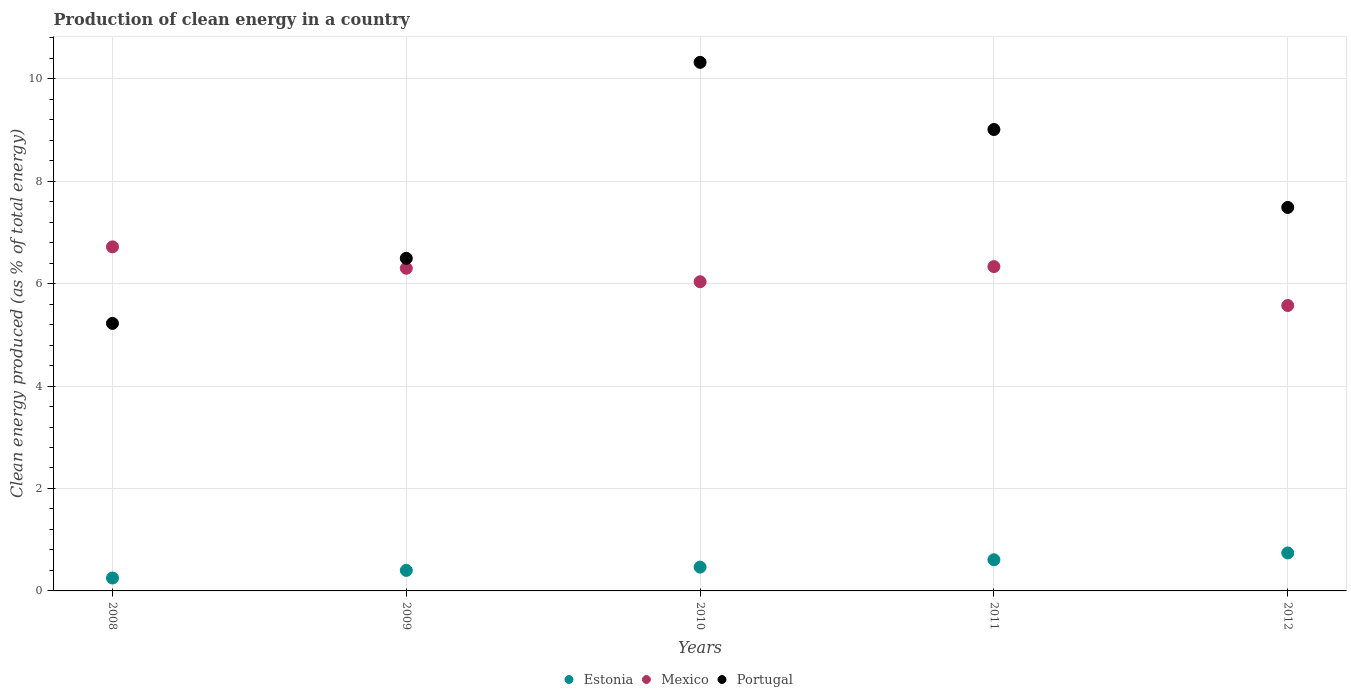How many different coloured dotlines are there?
Offer a terse response. 3. What is the percentage of clean energy produced in Estonia in 2012?
Provide a short and direct response. 0.74. Across all years, what is the maximum percentage of clean energy produced in Estonia?
Offer a very short reply. 0.74. Across all years, what is the minimum percentage of clean energy produced in Portugal?
Keep it short and to the point. 5.22. In which year was the percentage of clean energy produced in Portugal maximum?
Provide a succinct answer. 2010. In which year was the percentage of clean energy produced in Estonia minimum?
Make the answer very short. 2008. What is the total percentage of clean energy produced in Portugal in the graph?
Make the answer very short. 38.53. What is the difference between the percentage of clean energy produced in Mexico in 2008 and that in 2011?
Offer a very short reply. 0.39. What is the difference between the percentage of clean energy produced in Mexico in 2011 and the percentage of clean energy produced in Estonia in 2010?
Ensure brevity in your answer.  5.87. What is the average percentage of clean energy produced in Mexico per year?
Your response must be concise. 6.19. In the year 2011, what is the difference between the percentage of clean energy produced in Portugal and percentage of clean energy produced in Estonia?
Make the answer very short. 8.4. What is the ratio of the percentage of clean energy produced in Mexico in 2009 to that in 2011?
Give a very brief answer. 0.99. What is the difference between the highest and the second highest percentage of clean energy produced in Mexico?
Provide a short and direct response. 0.39. What is the difference between the highest and the lowest percentage of clean energy produced in Estonia?
Ensure brevity in your answer.  0.49. In how many years, is the percentage of clean energy produced in Portugal greater than the average percentage of clean energy produced in Portugal taken over all years?
Keep it short and to the point. 2. Is the sum of the percentage of clean energy produced in Estonia in 2010 and 2011 greater than the maximum percentage of clean energy produced in Mexico across all years?
Your answer should be very brief. No. Is the percentage of clean energy produced in Portugal strictly greater than the percentage of clean energy produced in Mexico over the years?
Give a very brief answer. No. Is the percentage of clean energy produced in Estonia strictly less than the percentage of clean energy produced in Portugal over the years?
Offer a very short reply. Yes. How many dotlines are there?
Provide a short and direct response. 3. What is the difference between two consecutive major ticks on the Y-axis?
Ensure brevity in your answer.  2. How are the legend labels stacked?
Ensure brevity in your answer.  Horizontal. What is the title of the graph?
Provide a short and direct response. Production of clean energy in a country. What is the label or title of the Y-axis?
Ensure brevity in your answer.  Clean energy produced (as % of total energy). What is the Clean energy produced (as % of total energy) of Estonia in 2008?
Your response must be concise. 0.25. What is the Clean energy produced (as % of total energy) in Mexico in 2008?
Your response must be concise. 6.72. What is the Clean energy produced (as % of total energy) of Portugal in 2008?
Provide a succinct answer. 5.22. What is the Clean energy produced (as % of total energy) in Estonia in 2009?
Offer a terse response. 0.4. What is the Clean energy produced (as % of total energy) of Mexico in 2009?
Keep it short and to the point. 6.3. What is the Clean energy produced (as % of total energy) of Portugal in 2009?
Offer a terse response. 6.49. What is the Clean energy produced (as % of total energy) in Estonia in 2010?
Ensure brevity in your answer.  0.46. What is the Clean energy produced (as % of total energy) in Mexico in 2010?
Offer a very short reply. 6.04. What is the Clean energy produced (as % of total energy) of Portugal in 2010?
Your answer should be compact. 10.32. What is the Clean energy produced (as % of total energy) in Estonia in 2011?
Keep it short and to the point. 0.61. What is the Clean energy produced (as % of total energy) of Mexico in 2011?
Ensure brevity in your answer.  6.33. What is the Clean energy produced (as % of total energy) of Portugal in 2011?
Provide a succinct answer. 9.01. What is the Clean energy produced (as % of total energy) of Estonia in 2012?
Provide a short and direct response. 0.74. What is the Clean energy produced (as % of total energy) in Mexico in 2012?
Keep it short and to the point. 5.57. What is the Clean energy produced (as % of total energy) of Portugal in 2012?
Provide a succinct answer. 7.49. Across all years, what is the maximum Clean energy produced (as % of total energy) of Estonia?
Make the answer very short. 0.74. Across all years, what is the maximum Clean energy produced (as % of total energy) in Mexico?
Offer a very short reply. 6.72. Across all years, what is the maximum Clean energy produced (as % of total energy) of Portugal?
Provide a succinct answer. 10.32. Across all years, what is the minimum Clean energy produced (as % of total energy) of Estonia?
Give a very brief answer. 0.25. Across all years, what is the minimum Clean energy produced (as % of total energy) in Mexico?
Provide a succinct answer. 5.57. Across all years, what is the minimum Clean energy produced (as % of total energy) of Portugal?
Give a very brief answer. 5.22. What is the total Clean energy produced (as % of total energy) of Estonia in the graph?
Make the answer very short. 2.47. What is the total Clean energy produced (as % of total energy) of Mexico in the graph?
Give a very brief answer. 30.96. What is the total Clean energy produced (as % of total energy) in Portugal in the graph?
Your answer should be very brief. 38.53. What is the difference between the Clean energy produced (as % of total energy) in Estonia in 2008 and that in 2009?
Provide a succinct answer. -0.15. What is the difference between the Clean energy produced (as % of total energy) of Mexico in 2008 and that in 2009?
Your answer should be compact. 0.42. What is the difference between the Clean energy produced (as % of total energy) of Portugal in 2008 and that in 2009?
Your answer should be very brief. -1.27. What is the difference between the Clean energy produced (as % of total energy) in Estonia in 2008 and that in 2010?
Give a very brief answer. -0.21. What is the difference between the Clean energy produced (as % of total energy) in Mexico in 2008 and that in 2010?
Provide a short and direct response. 0.68. What is the difference between the Clean energy produced (as % of total energy) of Portugal in 2008 and that in 2010?
Provide a short and direct response. -5.1. What is the difference between the Clean energy produced (as % of total energy) of Estonia in 2008 and that in 2011?
Provide a short and direct response. -0.36. What is the difference between the Clean energy produced (as % of total energy) of Mexico in 2008 and that in 2011?
Ensure brevity in your answer.  0.39. What is the difference between the Clean energy produced (as % of total energy) in Portugal in 2008 and that in 2011?
Offer a very short reply. -3.79. What is the difference between the Clean energy produced (as % of total energy) of Estonia in 2008 and that in 2012?
Offer a very short reply. -0.49. What is the difference between the Clean energy produced (as % of total energy) of Mexico in 2008 and that in 2012?
Provide a succinct answer. 1.15. What is the difference between the Clean energy produced (as % of total energy) of Portugal in 2008 and that in 2012?
Provide a short and direct response. -2.26. What is the difference between the Clean energy produced (as % of total energy) of Estonia in 2009 and that in 2010?
Make the answer very short. -0.06. What is the difference between the Clean energy produced (as % of total energy) in Mexico in 2009 and that in 2010?
Your response must be concise. 0.26. What is the difference between the Clean energy produced (as % of total energy) in Portugal in 2009 and that in 2010?
Give a very brief answer. -3.83. What is the difference between the Clean energy produced (as % of total energy) of Estonia in 2009 and that in 2011?
Your response must be concise. -0.21. What is the difference between the Clean energy produced (as % of total energy) of Mexico in 2009 and that in 2011?
Make the answer very short. -0.03. What is the difference between the Clean energy produced (as % of total energy) of Portugal in 2009 and that in 2011?
Provide a succinct answer. -2.52. What is the difference between the Clean energy produced (as % of total energy) in Estonia in 2009 and that in 2012?
Keep it short and to the point. -0.34. What is the difference between the Clean energy produced (as % of total energy) in Mexico in 2009 and that in 2012?
Provide a short and direct response. 0.73. What is the difference between the Clean energy produced (as % of total energy) of Portugal in 2009 and that in 2012?
Keep it short and to the point. -0.99. What is the difference between the Clean energy produced (as % of total energy) in Estonia in 2010 and that in 2011?
Offer a terse response. -0.14. What is the difference between the Clean energy produced (as % of total energy) of Mexico in 2010 and that in 2011?
Your answer should be very brief. -0.3. What is the difference between the Clean energy produced (as % of total energy) of Portugal in 2010 and that in 2011?
Provide a succinct answer. 1.31. What is the difference between the Clean energy produced (as % of total energy) in Estonia in 2010 and that in 2012?
Provide a short and direct response. -0.28. What is the difference between the Clean energy produced (as % of total energy) in Mexico in 2010 and that in 2012?
Provide a short and direct response. 0.46. What is the difference between the Clean energy produced (as % of total energy) in Portugal in 2010 and that in 2012?
Offer a terse response. 2.83. What is the difference between the Clean energy produced (as % of total energy) in Estonia in 2011 and that in 2012?
Provide a short and direct response. -0.13. What is the difference between the Clean energy produced (as % of total energy) of Mexico in 2011 and that in 2012?
Make the answer very short. 0.76. What is the difference between the Clean energy produced (as % of total energy) of Portugal in 2011 and that in 2012?
Keep it short and to the point. 1.52. What is the difference between the Clean energy produced (as % of total energy) of Estonia in 2008 and the Clean energy produced (as % of total energy) of Mexico in 2009?
Provide a succinct answer. -6.05. What is the difference between the Clean energy produced (as % of total energy) of Estonia in 2008 and the Clean energy produced (as % of total energy) of Portugal in 2009?
Give a very brief answer. -6.24. What is the difference between the Clean energy produced (as % of total energy) in Mexico in 2008 and the Clean energy produced (as % of total energy) in Portugal in 2009?
Your answer should be very brief. 0.22. What is the difference between the Clean energy produced (as % of total energy) of Estonia in 2008 and the Clean energy produced (as % of total energy) of Mexico in 2010?
Provide a succinct answer. -5.78. What is the difference between the Clean energy produced (as % of total energy) in Estonia in 2008 and the Clean energy produced (as % of total energy) in Portugal in 2010?
Give a very brief answer. -10.07. What is the difference between the Clean energy produced (as % of total energy) in Mexico in 2008 and the Clean energy produced (as % of total energy) in Portugal in 2010?
Keep it short and to the point. -3.6. What is the difference between the Clean energy produced (as % of total energy) of Estonia in 2008 and the Clean energy produced (as % of total energy) of Mexico in 2011?
Keep it short and to the point. -6.08. What is the difference between the Clean energy produced (as % of total energy) in Estonia in 2008 and the Clean energy produced (as % of total energy) in Portugal in 2011?
Offer a terse response. -8.76. What is the difference between the Clean energy produced (as % of total energy) in Mexico in 2008 and the Clean energy produced (as % of total energy) in Portugal in 2011?
Offer a very short reply. -2.29. What is the difference between the Clean energy produced (as % of total energy) of Estonia in 2008 and the Clean energy produced (as % of total energy) of Mexico in 2012?
Offer a terse response. -5.32. What is the difference between the Clean energy produced (as % of total energy) in Estonia in 2008 and the Clean energy produced (as % of total energy) in Portugal in 2012?
Your answer should be very brief. -7.24. What is the difference between the Clean energy produced (as % of total energy) in Mexico in 2008 and the Clean energy produced (as % of total energy) in Portugal in 2012?
Your answer should be compact. -0.77. What is the difference between the Clean energy produced (as % of total energy) in Estonia in 2009 and the Clean energy produced (as % of total energy) in Mexico in 2010?
Provide a succinct answer. -5.64. What is the difference between the Clean energy produced (as % of total energy) in Estonia in 2009 and the Clean energy produced (as % of total energy) in Portugal in 2010?
Your answer should be compact. -9.92. What is the difference between the Clean energy produced (as % of total energy) in Mexico in 2009 and the Clean energy produced (as % of total energy) in Portugal in 2010?
Your response must be concise. -4.02. What is the difference between the Clean energy produced (as % of total energy) of Estonia in 2009 and the Clean energy produced (as % of total energy) of Mexico in 2011?
Make the answer very short. -5.93. What is the difference between the Clean energy produced (as % of total energy) of Estonia in 2009 and the Clean energy produced (as % of total energy) of Portugal in 2011?
Offer a very short reply. -8.61. What is the difference between the Clean energy produced (as % of total energy) in Mexico in 2009 and the Clean energy produced (as % of total energy) in Portugal in 2011?
Ensure brevity in your answer.  -2.71. What is the difference between the Clean energy produced (as % of total energy) in Estonia in 2009 and the Clean energy produced (as % of total energy) in Mexico in 2012?
Your answer should be compact. -5.17. What is the difference between the Clean energy produced (as % of total energy) in Estonia in 2009 and the Clean energy produced (as % of total energy) in Portugal in 2012?
Ensure brevity in your answer.  -7.09. What is the difference between the Clean energy produced (as % of total energy) in Mexico in 2009 and the Clean energy produced (as % of total energy) in Portugal in 2012?
Give a very brief answer. -1.19. What is the difference between the Clean energy produced (as % of total energy) in Estonia in 2010 and the Clean energy produced (as % of total energy) in Mexico in 2011?
Your response must be concise. -5.87. What is the difference between the Clean energy produced (as % of total energy) of Estonia in 2010 and the Clean energy produced (as % of total energy) of Portugal in 2011?
Your response must be concise. -8.54. What is the difference between the Clean energy produced (as % of total energy) in Mexico in 2010 and the Clean energy produced (as % of total energy) in Portugal in 2011?
Make the answer very short. -2.97. What is the difference between the Clean energy produced (as % of total energy) in Estonia in 2010 and the Clean energy produced (as % of total energy) in Mexico in 2012?
Your answer should be very brief. -5.11. What is the difference between the Clean energy produced (as % of total energy) of Estonia in 2010 and the Clean energy produced (as % of total energy) of Portugal in 2012?
Make the answer very short. -7.02. What is the difference between the Clean energy produced (as % of total energy) in Mexico in 2010 and the Clean energy produced (as % of total energy) in Portugal in 2012?
Give a very brief answer. -1.45. What is the difference between the Clean energy produced (as % of total energy) in Estonia in 2011 and the Clean energy produced (as % of total energy) in Mexico in 2012?
Make the answer very short. -4.96. What is the difference between the Clean energy produced (as % of total energy) of Estonia in 2011 and the Clean energy produced (as % of total energy) of Portugal in 2012?
Your answer should be very brief. -6.88. What is the difference between the Clean energy produced (as % of total energy) of Mexico in 2011 and the Clean energy produced (as % of total energy) of Portugal in 2012?
Offer a very short reply. -1.16. What is the average Clean energy produced (as % of total energy) of Estonia per year?
Ensure brevity in your answer.  0.49. What is the average Clean energy produced (as % of total energy) in Mexico per year?
Offer a terse response. 6.19. What is the average Clean energy produced (as % of total energy) of Portugal per year?
Offer a terse response. 7.71. In the year 2008, what is the difference between the Clean energy produced (as % of total energy) in Estonia and Clean energy produced (as % of total energy) in Mexico?
Offer a very short reply. -6.47. In the year 2008, what is the difference between the Clean energy produced (as % of total energy) of Estonia and Clean energy produced (as % of total energy) of Portugal?
Your answer should be very brief. -4.97. In the year 2008, what is the difference between the Clean energy produced (as % of total energy) of Mexico and Clean energy produced (as % of total energy) of Portugal?
Provide a succinct answer. 1.49. In the year 2009, what is the difference between the Clean energy produced (as % of total energy) in Estonia and Clean energy produced (as % of total energy) in Mexico?
Your answer should be compact. -5.9. In the year 2009, what is the difference between the Clean energy produced (as % of total energy) of Estonia and Clean energy produced (as % of total energy) of Portugal?
Your answer should be very brief. -6.09. In the year 2009, what is the difference between the Clean energy produced (as % of total energy) in Mexico and Clean energy produced (as % of total energy) in Portugal?
Provide a short and direct response. -0.19. In the year 2010, what is the difference between the Clean energy produced (as % of total energy) in Estonia and Clean energy produced (as % of total energy) in Mexico?
Keep it short and to the point. -5.57. In the year 2010, what is the difference between the Clean energy produced (as % of total energy) of Estonia and Clean energy produced (as % of total energy) of Portugal?
Give a very brief answer. -9.85. In the year 2010, what is the difference between the Clean energy produced (as % of total energy) of Mexico and Clean energy produced (as % of total energy) of Portugal?
Your response must be concise. -4.28. In the year 2011, what is the difference between the Clean energy produced (as % of total energy) of Estonia and Clean energy produced (as % of total energy) of Mexico?
Provide a short and direct response. -5.72. In the year 2011, what is the difference between the Clean energy produced (as % of total energy) of Estonia and Clean energy produced (as % of total energy) of Portugal?
Give a very brief answer. -8.4. In the year 2011, what is the difference between the Clean energy produced (as % of total energy) in Mexico and Clean energy produced (as % of total energy) in Portugal?
Your response must be concise. -2.68. In the year 2012, what is the difference between the Clean energy produced (as % of total energy) in Estonia and Clean energy produced (as % of total energy) in Mexico?
Keep it short and to the point. -4.83. In the year 2012, what is the difference between the Clean energy produced (as % of total energy) in Estonia and Clean energy produced (as % of total energy) in Portugal?
Your response must be concise. -6.75. In the year 2012, what is the difference between the Clean energy produced (as % of total energy) in Mexico and Clean energy produced (as % of total energy) in Portugal?
Provide a short and direct response. -1.91. What is the ratio of the Clean energy produced (as % of total energy) in Estonia in 2008 to that in 2009?
Provide a succinct answer. 0.63. What is the ratio of the Clean energy produced (as % of total energy) in Mexico in 2008 to that in 2009?
Your answer should be very brief. 1.07. What is the ratio of the Clean energy produced (as % of total energy) of Portugal in 2008 to that in 2009?
Provide a short and direct response. 0.8. What is the ratio of the Clean energy produced (as % of total energy) in Estonia in 2008 to that in 2010?
Your response must be concise. 0.54. What is the ratio of the Clean energy produced (as % of total energy) of Mexico in 2008 to that in 2010?
Your answer should be compact. 1.11. What is the ratio of the Clean energy produced (as % of total energy) of Portugal in 2008 to that in 2010?
Provide a succinct answer. 0.51. What is the ratio of the Clean energy produced (as % of total energy) in Estonia in 2008 to that in 2011?
Give a very brief answer. 0.41. What is the ratio of the Clean energy produced (as % of total energy) of Mexico in 2008 to that in 2011?
Your answer should be compact. 1.06. What is the ratio of the Clean energy produced (as % of total energy) in Portugal in 2008 to that in 2011?
Ensure brevity in your answer.  0.58. What is the ratio of the Clean energy produced (as % of total energy) of Estonia in 2008 to that in 2012?
Give a very brief answer. 0.34. What is the ratio of the Clean energy produced (as % of total energy) of Mexico in 2008 to that in 2012?
Your answer should be very brief. 1.21. What is the ratio of the Clean energy produced (as % of total energy) of Portugal in 2008 to that in 2012?
Provide a succinct answer. 0.7. What is the ratio of the Clean energy produced (as % of total energy) in Estonia in 2009 to that in 2010?
Offer a terse response. 0.86. What is the ratio of the Clean energy produced (as % of total energy) of Mexico in 2009 to that in 2010?
Your response must be concise. 1.04. What is the ratio of the Clean energy produced (as % of total energy) in Portugal in 2009 to that in 2010?
Your response must be concise. 0.63. What is the ratio of the Clean energy produced (as % of total energy) of Estonia in 2009 to that in 2011?
Offer a very short reply. 0.66. What is the ratio of the Clean energy produced (as % of total energy) of Portugal in 2009 to that in 2011?
Offer a terse response. 0.72. What is the ratio of the Clean energy produced (as % of total energy) of Estonia in 2009 to that in 2012?
Make the answer very short. 0.54. What is the ratio of the Clean energy produced (as % of total energy) of Mexico in 2009 to that in 2012?
Keep it short and to the point. 1.13. What is the ratio of the Clean energy produced (as % of total energy) in Portugal in 2009 to that in 2012?
Offer a terse response. 0.87. What is the ratio of the Clean energy produced (as % of total energy) in Estonia in 2010 to that in 2011?
Your answer should be compact. 0.76. What is the ratio of the Clean energy produced (as % of total energy) of Mexico in 2010 to that in 2011?
Your answer should be compact. 0.95. What is the ratio of the Clean energy produced (as % of total energy) of Portugal in 2010 to that in 2011?
Make the answer very short. 1.15. What is the ratio of the Clean energy produced (as % of total energy) of Estonia in 2010 to that in 2012?
Make the answer very short. 0.63. What is the ratio of the Clean energy produced (as % of total energy) in Portugal in 2010 to that in 2012?
Your response must be concise. 1.38. What is the ratio of the Clean energy produced (as % of total energy) of Estonia in 2011 to that in 2012?
Your response must be concise. 0.82. What is the ratio of the Clean energy produced (as % of total energy) of Mexico in 2011 to that in 2012?
Provide a short and direct response. 1.14. What is the ratio of the Clean energy produced (as % of total energy) in Portugal in 2011 to that in 2012?
Provide a succinct answer. 1.2. What is the difference between the highest and the second highest Clean energy produced (as % of total energy) in Estonia?
Your answer should be compact. 0.13. What is the difference between the highest and the second highest Clean energy produced (as % of total energy) in Mexico?
Ensure brevity in your answer.  0.39. What is the difference between the highest and the second highest Clean energy produced (as % of total energy) in Portugal?
Your answer should be very brief. 1.31. What is the difference between the highest and the lowest Clean energy produced (as % of total energy) of Estonia?
Keep it short and to the point. 0.49. What is the difference between the highest and the lowest Clean energy produced (as % of total energy) of Mexico?
Your response must be concise. 1.15. What is the difference between the highest and the lowest Clean energy produced (as % of total energy) of Portugal?
Your answer should be very brief. 5.1. 